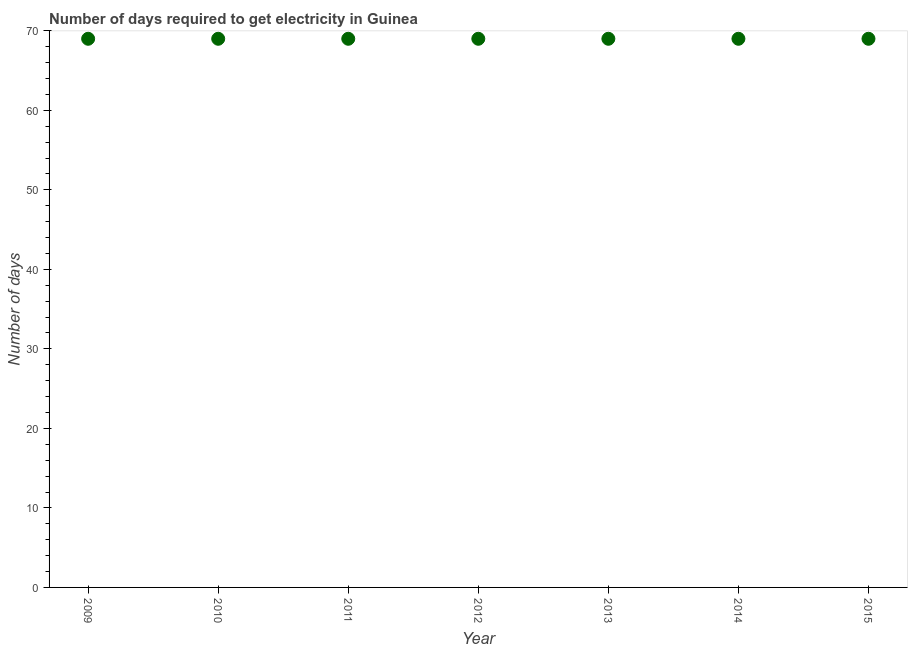What is the time to get electricity in 2014?
Provide a succinct answer. 69. Across all years, what is the maximum time to get electricity?
Give a very brief answer. 69. Across all years, what is the minimum time to get electricity?
Give a very brief answer. 69. In which year was the time to get electricity maximum?
Make the answer very short. 2009. What is the sum of the time to get electricity?
Give a very brief answer. 483. What is the difference between the time to get electricity in 2012 and 2013?
Ensure brevity in your answer.  0. What is the average time to get electricity per year?
Your response must be concise. 69. What is the median time to get electricity?
Your response must be concise. 69. Is the difference between the time to get electricity in 2013 and 2014 greater than the difference between any two years?
Provide a succinct answer. Yes. Is the sum of the time to get electricity in 2012 and 2015 greater than the maximum time to get electricity across all years?
Your response must be concise. Yes. How many years are there in the graph?
Ensure brevity in your answer.  7. Are the values on the major ticks of Y-axis written in scientific E-notation?
Ensure brevity in your answer.  No. What is the title of the graph?
Keep it short and to the point. Number of days required to get electricity in Guinea. What is the label or title of the X-axis?
Your response must be concise. Year. What is the label or title of the Y-axis?
Ensure brevity in your answer.  Number of days. What is the Number of days in 2013?
Your response must be concise. 69. What is the Number of days in 2015?
Your answer should be very brief. 69. What is the difference between the Number of days in 2009 and 2010?
Ensure brevity in your answer.  0. What is the difference between the Number of days in 2009 and 2011?
Your answer should be very brief. 0. What is the difference between the Number of days in 2009 and 2013?
Keep it short and to the point. 0. What is the difference between the Number of days in 2010 and 2012?
Make the answer very short. 0. What is the difference between the Number of days in 2010 and 2015?
Offer a terse response. 0. What is the difference between the Number of days in 2011 and 2013?
Give a very brief answer. 0. What is the difference between the Number of days in 2012 and 2013?
Your response must be concise. 0. What is the ratio of the Number of days in 2009 to that in 2011?
Provide a succinct answer. 1. What is the ratio of the Number of days in 2009 to that in 2012?
Offer a very short reply. 1. What is the ratio of the Number of days in 2009 to that in 2014?
Your answer should be compact. 1. What is the ratio of the Number of days in 2010 to that in 2011?
Your response must be concise. 1. What is the ratio of the Number of days in 2010 to that in 2012?
Offer a terse response. 1. What is the ratio of the Number of days in 2010 to that in 2014?
Ensure brevity in your answer.  1. What is the ratio of the Number of days in 2010 to that in 2015?
Your answer should be very brief. 1. What is the ratio of the Number of days in 2011 to that in 2015?
Your answer should be very brief. 1. What is the ratio of the Number of days in 2012 to that in 2013?
Provide a succinct answer. 1. What is the ratio of the Number of days in 2012 to that in 2015?
Ensure brevity in your answer.  1. What is the ratio of the Number of days in 2013 to that in 2014?
Offer a terse response. 1. What is the ratio of the Number of days in 2013 to that in 2015?
Your answer should be compact. 1. 